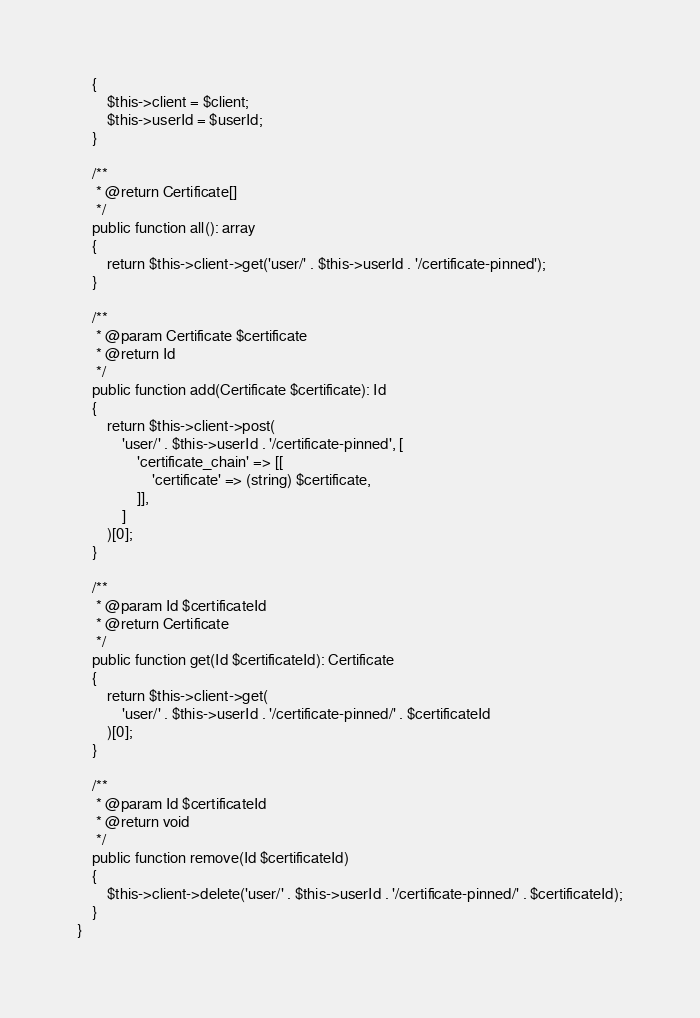<code> <loc_0><loc_0><loc_500><loc_500><_PHP_>    {
        $this->client = $client;
        $this->userId = $userId;
    }

    /**
     * @return Certificate[]
     */
    public function all(): array
    {
        return $this->client->get('user/' . $this->userId . '/certificate-pinned');
    }

    /**
     * @param Certificate $certificate
     * @return Id
     */
    public function add(Certificate $certificate): Id
    {
        return $this->client->post(
            'user/' . $this->userId . '/certificate-pinned', [
                'certificate_chain' => [[
                    'certificate' => (string) $certificate,
                ]],
            ]
        )[0];
    }

    /**
     * @param Id $certificateId
     * @return Certificate
     */
    public function get(Id $certificateId): Certificate
    {
        return $this->client->get(
            'user/' . $this->userId . '/certificate-pinned/' . $certificateId
        )[0];
    }

    /**
     * @param Id $certificateId
     * @return void
     */
    public function remove(Id $certificateId)
    {
        $this->client->delete('user/' . $this->userId . '/certificate-pinned/' . $certificateId);
    }
}
</code> 